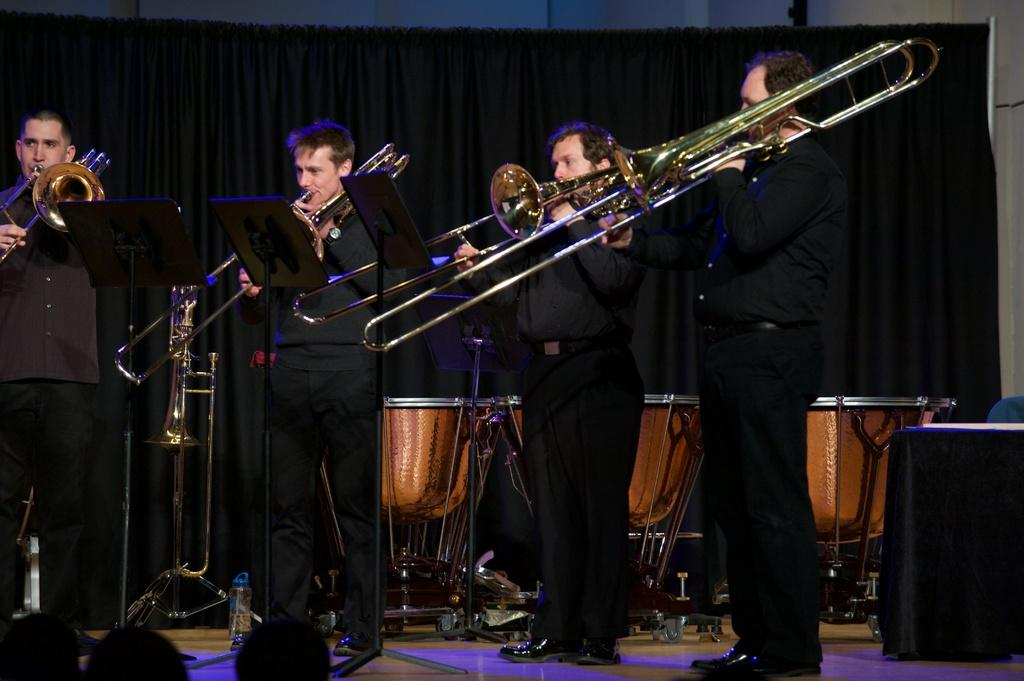What is the person in the image wearing? The person is wearing a black dress in the image. What is the person doing while wearing the black dress? The person is playing music. Who is present in front of the person while they are playing music? There are audience members in front of the person. What musical instrument can be seen behind the person? There are drums behind the person. What is the color of the background in the image? The background of the image is black. Can you tell me how many cows are in the flock behind the person in the image? There are no cows or flock present in the image; it features a person playing music with drums in the background. 